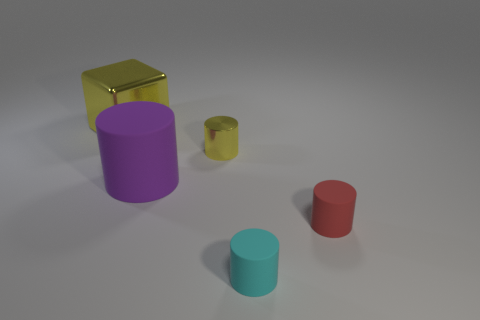Is the thing to the left of the large purple matte thing made of the same material as the cyan thing?
Your response must be concise. No. Is the number of purple things that are in front of the large rubber object greater than the number of cyan rubber things that are to the right of the red cylinder?
Your answer should be compact. No. How big is the yellow block?
Your response must be concise. Large. There is a small yellow thing that is made of the same material as the large yellow thing; what shape is it?
Your answer should be compact. Cylinder. There is a matte thing that is on the left side of the small shiny thing; is it the same shape as the red object?
Give a very brief answer. Yes. What number of things are either cyan matte cylinders or yellow metal objects?
Make the answer very short. 3. What is the thing that is both on the left side of the small yellow metal cylinder and right of the big yellow metal thing made of?
Your response must be concise. Rubber. Is the red matte cylinder the same size as the purple matte cylinder?
Provide a short and direct response. No. There is a yellow object behind the metal object that is in front of the yellow cube; what size is it?
Offer a terse response. Large. What number of things are in front of the purple rubber object and behind the cyan matte cylinder?
Give a very brief answer. 1. 